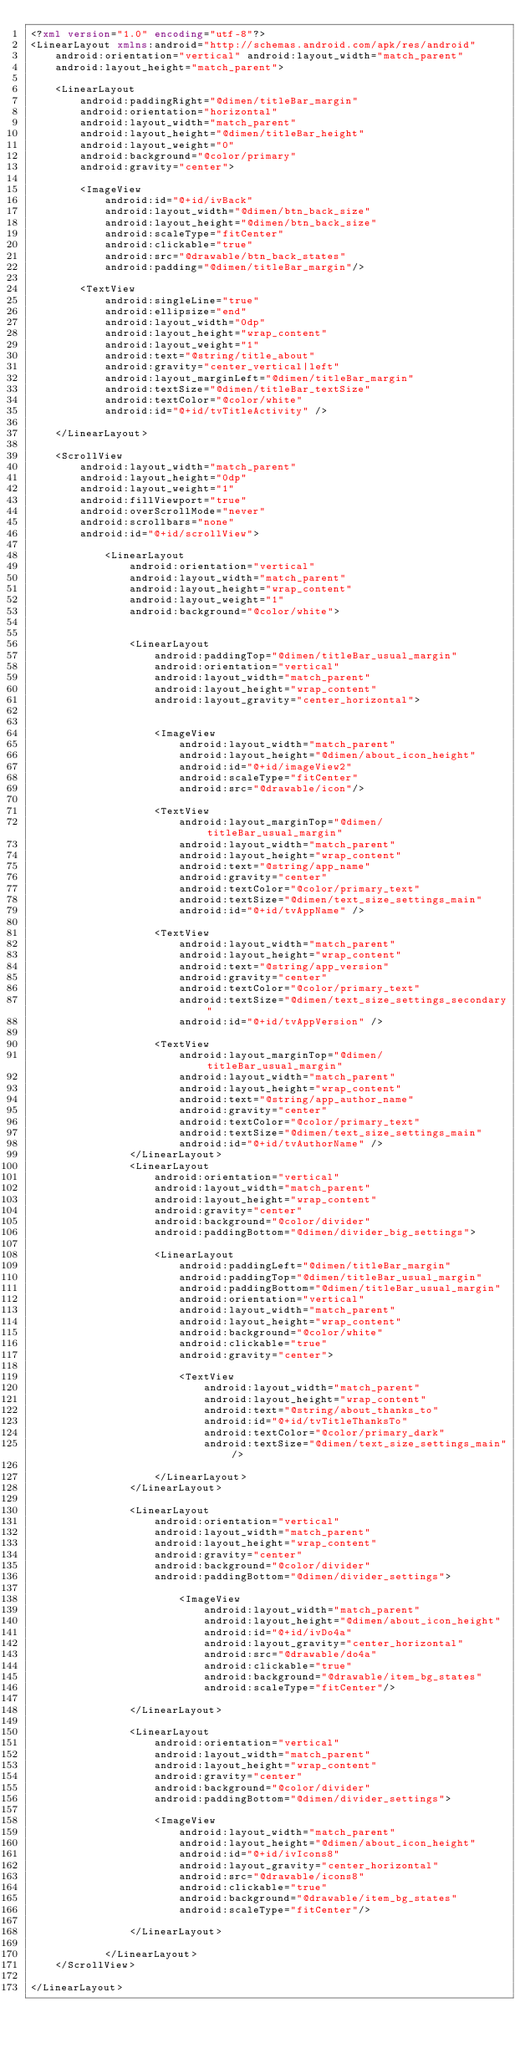<code> <loc_0><loc_0><loc_500><loc_500><_XML_><?xml version="1.0" encoding="utf-8"?>
<LinearLayout xmlns:android="http://schemas.android.com/apk/res/android"
    android:orientation="vertical" android:layout_width="match_parent"
    android:layout_height="match_parent">

    <LinearLayout
        android:paddingRight="@dimen/titleBar_margin"
        android:orientation="horizontal"
        android:layout_width="match_parent"
        android:layout_height="@dimen/titleBar_height"
        android:layout_weight="0"
        android:background="@color/primary"
        android:gravity="center">

        <ImageView
            android:id="@+id/ivBack"
            android:layout_width="@dimen/btn_back_size"
            android:layout_height="@dimen/btn_back_size"
            android:scaleType="fitCenter"
            android:clickable="true"
            android:src="@drawable/btn_back_states"
            android:padding="@dimen/titleBar_margin"/>

        <TextView
            android:singleLine="true"
            android:ellipsize="end"
            android:layout_width="0dp"
            android:layout_height="wrap_content"
            android:layout_weight="1"
            android:text="@string/title_about"
            android:gravity="center_vertical|left"
            android:layout_marginLeft="@dimen/titleBar_margin"
            android:textSize="@dimen/titleBar_textSize"
            android:textColor="@color/white"
            android:id="@+id/tvTitleActivity" />

    </LinearLayout>

    <ScrollView
        android:layout_width="match_parent"
        android:layout_height="0dp"
        android:layout_weight="1"
        android:fillViewport="true"
        android:overScrollMode="never"
        android:scrollbars="none"
        android:id="@+id/scrollView">

            <LinearLayout
                android:orientation="vertical"
                android:layout_width="match_parent"
                android:layout_height="wrap_content"
                android:layout_weight="1"
                android:background="@color/white">


                <LinearLayout
                    android:paddingTop="@dimen/titleBar_usual_margin"
                    android:orientation="vertical"
                    android:layout_width="match_parent"
                    android:layout_height="wrap_content"
                    android:layout_gravity="center_horizontal">


                    <ImageView
                        android:layout_width="match_parent"
                        android:layout_height="@dimen/about_icon_height"
                        android:id="@+id/imageView2"
                        android:scaleType="fitCenter"
                        android:src="@drawable/icon"/>

                    <TextView
                        android:layout_marginTop="@dimen/titleBar_usual_margin"
                        android:layout_width="match_parent"
                        android:layout_height="wrap_content"
                        android:text="@string/app_name"
                        android:gravity="center"
                        android:textColor="@color/primary_text"
                        android:textSize="@dimen/text_size_settings_main"
                        android:id="@+id/tvAppName" />

                    <TextView
                        android:layout_width="match_parent"
                        android:layout_height="wrap_content"
                        android:text="@string/app_version"
                        android:gravity="center"
                        android:textColor="@color/primary_text"
                        android:textSize="@dimen/text_size_settings_secondary"
                        android:id="@+id/tvAppVersion" />

                    <TextView
                        android:layout_marginTop="@dimen/titleBar_usual_margin"
                        android:layout_width="match_parent"
                        android:layout_height="wrap_content"
                        android:text="@string/app_author_name"
                        android:gravity="center"
                        android:textColor="@color/primary_text"
                        android:textSize="@dimen/text_size_settings_main"
                        android:id="@+id/tvAuthorName" />
                </LinearLayout>
                <LinearLayout
                    android:orientation="vertical"
                    android:layout_width="match_parent"
                    android:layout_height="wrap_content"
                    android:gravity="center"
                    android:background="@color/divider"
                    android:paddingBottom="@dimen/divider_big_settings">

                    <LinearLayout
                        android:paddingLeft="@dimen/titleBar_margin"
                        android:paddingTop="@dimen/titleBar_usual_margin"
                        android:paddingBottom="@dimen/titleBar_usual_margin"
                        android:orientation="vertical"
                        android:layout_width="match_parent"
                        android:layout_height="wrap_content"
                        android:background="@color/white"
                        android:clickable="true"
                        android:gravity="center">

                        <TextView
                            android:layout_width="match_parent"
                            android:layout_height="wrap_content"
                            android:text="@string/about_thanks_to"
                            android:id="@+id/tvTitleThanksTo"
                            android:textColor="@color/primary_dark"
                            android:textSize="@dimen/text_size_settings_main"/>

                    </LinearLayout>
                </LinearLayout>

                <LinearLayout
                    android:orientation="vertical"
                    android:layout_width="match_parent"
                    android:layout_height="wrap_content"
                    android:gravity="center"
                    android:background="@color/divider"
                    android:paddingBottom="@dimen/divider_settings">

                        <ImageView
                            android:layout_width="match_parent"
                            android:layout_height="@dimen/about_icon_height"
                            android:id="@+id/ivDo4a"
                            android:layout_gravity="center_horizontal"
                            android:src="@drawable/do4a"
                            android:clickable="true"
                            android:background="@drawable/item_bg_states"
                            android:scaleType="fitCenter"/>

                </LinearLayout>

                <LinearLayout
                    android:orientation="vertical"
                    android:layout_width="match_parent"
                    android:layout_height="wrap_content"
                    android:gravity="center"
                    android:background="@color/divider"
                    android:paddingBottom="@dimen/divider_settings">

                    <ImageView
                        android:layout_width="match_parent"
                        android:layout_height="@dimen/about_icon_height"
                        android:id="@+id/ivIcons8"
                        android:layout_gravity="center_horizontal"
                        android:src="@drawable/icons8"
                        android:clickable="true"
                        android:background="@drawable/item_bg_states"
                        android:scaleType="fitCenter"/>

                </LinearLayout>

            </LinearLayout>
    </ScrollView>

</LinearLayout></code> 